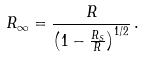<formula> <loc_0><loc_0><loc_500><loc_500>R _ { \infty } = \frac { R } { \left ( 1 - \frac { R _ { S } } { R } \right ) ^ { 1 / 2 } } \, .</formula> 